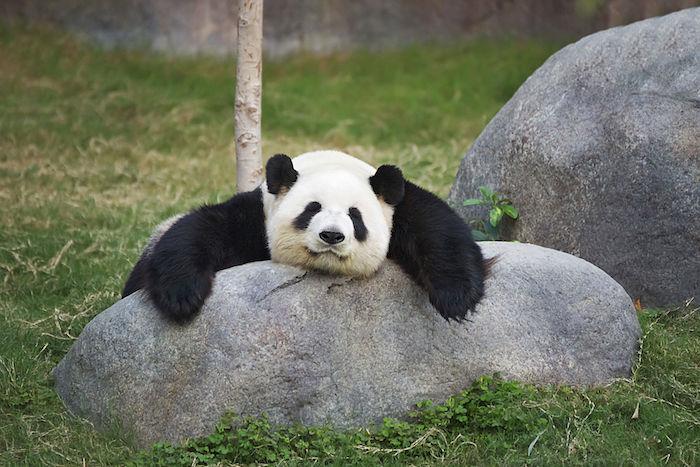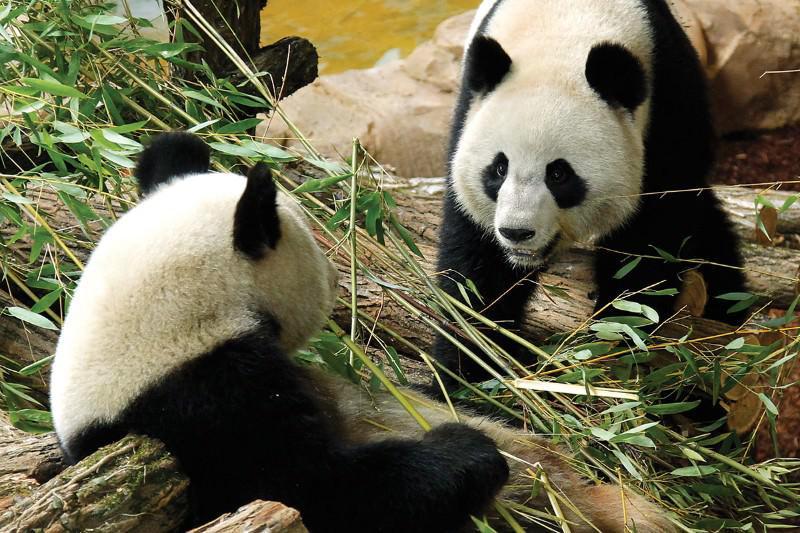The first image is the image on the left, the second image is the image on the right. Analyze the images presented: Is the assertion "One image contains twice as many pandas as the other image and features two pandas facing generally toward each other." valid? Answer yes or no. Yes. The first image is the image on the left, the second image is the image on the right. For the images displayed, is the sentence "There are at most two panda bears." factually correct? Answer yes or no. No. 